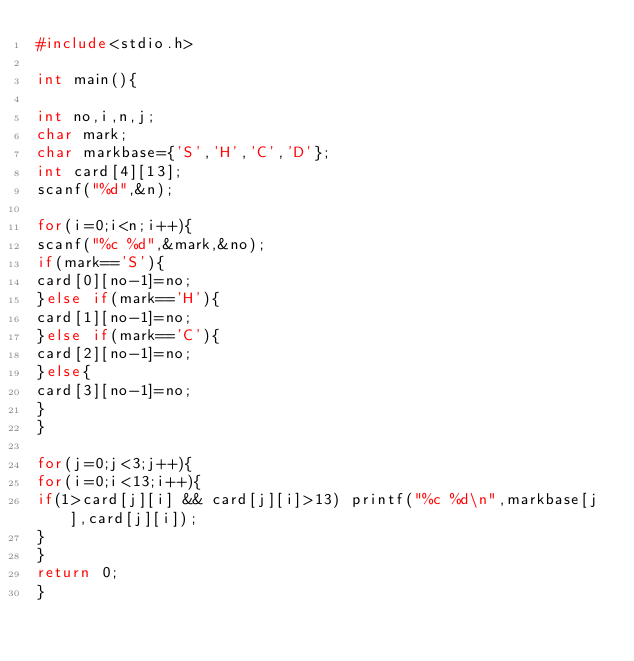Convert code to text. <code><loc_0><loc_0><loc_500><loc_500><_C_>#include<stdio.h>

int main(){

int no,i,n,j;
char mark;
char markbase={'S','H','C','D'};
int card[4][13];
scanf("%d",&n);

for(i=0;i<n;i++){
scanf("%c %d",&mark,&no);
if(mark=='S'){
card[0][no-1]=no;
}else if(mark=='H'){
card[1][no-1]=no;
}else if(mark=='C'){
card[2][no-1]=no;
}else{
card[3][no-1]=no;
}
}

for(j=0;j<3;j++){
for(i=0;i<13;i++){
if(1>card[j][i] && card[j][i]>13) printf("%c %d\n",markbase[j],card[j][i]);
}
}
return 0;
}</code> 